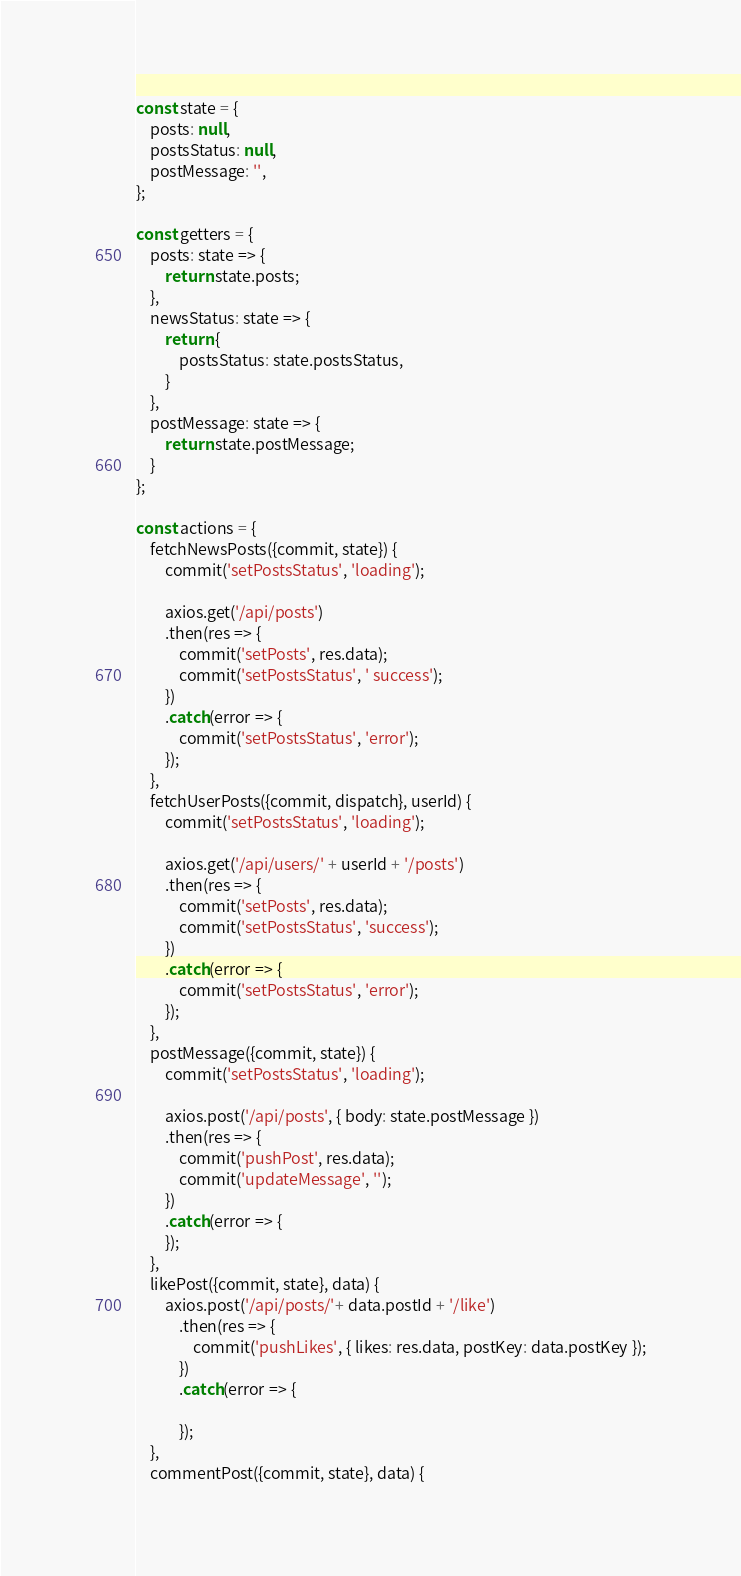<code> <loc_0><loc_0><loc_500><loc_500><_JavaScript_>const state = {
    posts: null,
    postsStatus: null,
    postMessage: '',
};

const getters = {
    posts: state => {
        return state.posts;
    },
    newsStatus: state => {
        return {
            postsStatus: state.postsStatus,
        }
    },
    postMessage: state => {
        return state.postMessage;
    }
};

const actions = {
    fetchNewsPosts({commit, state}) {
        commit('setPostsStatus', 'loading');

        axios.get('/api/posts')
        .then(res => {
            commit('setPosts', res.data);
            commit('setPostsStatus', ' success');
        })
        .catch(error => {
            commit('setPostsStatus', 'error');
        });
    },
    fetchUserPosts({commit, dispatch}, userId) {
        commit('setPostsStatus', 'loading');

        axios.get('/api/users/' + userId + '/posts')
        .then(res => {
            commit('setPosts', res.data);
            commit('setPostsStatus', 'success');
        })
        .catch(error => {
            commit('setPostsStatus', 'error');
        });
    },
    postMessage({commit, state}) {
        commit('setPostsStatus', 'loading');

        axios.post('/api/posts', { body: state.postMessage })
        .then(res => {
            commit('pushPost', res.data);
            commit('updateMessage', ''); 
        })
        .catch(error => {
        });
    },
    likePost({commit, state}, data) {
        axios.post('/api/posts/'+ data.postId + '/like')
            .then(res => {
                commit('pushLikes', { likes: res.data, postKey: data.postKey });
            })
            .catch(error => {

            });
    },
    commentPost({commit, state}, data) {</code> 